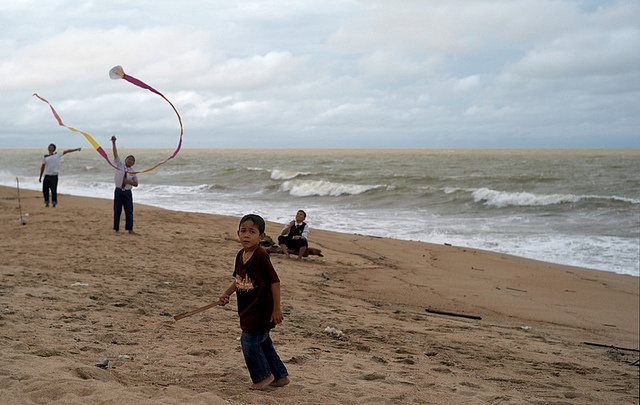Describe the objects in this image and their specific colors. I can see people in white, black, maroon, and brown tones, people in white, black, gray, and maroon tones, kite in white, darkgray, purple, gray, and lightgray tones, people in white, black, maroon, gray, and darkgray tones, and people in white, black, darkgray, gray, and maroon tones in this image. 